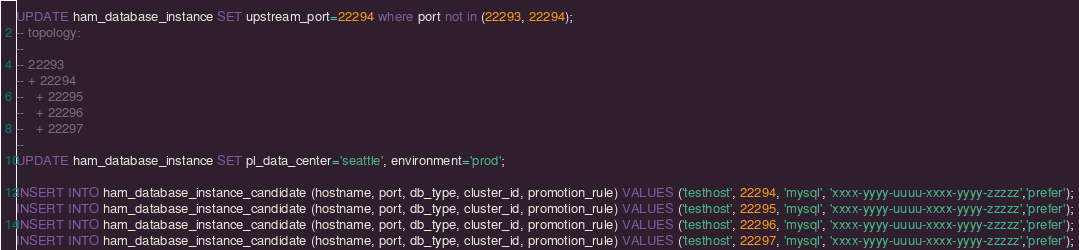<code> <loc_0><loc_0><loc_500><loc_500><_SQL_>UPDATE ham_database_instance SET upstream_port=22294 where port not in (22293, 22294);
-- topology:
--
-- 22293
-- + 22294
--   + 22295
--   + 22296
--   + 22297
--
UPDATE ham_database_instance SET pl_data_center='seattle', environment='prod';

INSERT INTO ham_database_instance_candidate (hostname, port, db_type, cluster_id, promotion_rule) VALUES ('testhost', 22294, 'mysql', 'xxxx-yyyy-uuuu-xxxx-yyyy-zzzzz','prefer');
INSERT INTO ham_database_instance_candidate (hostname, port, db_type, cluster_id, promotion_rule) VALUES ('testhost', 22295, 'mysql', 'xxxx-yyyy-uuuu-xxxx-yyyy-zzzzz','prefer');
INSERT INTO ham_database_instance_candidate (hostname, port, db_type, cluster_id, promotion_rule) VALUES ('testhost', 22296, 'mysql', 'xxxx-yyyy-uuuu-xxxx-yyyy-zzzzz','prefer');
INSERT INTO ham_database_instance_candidate (hostname, port, db_type, cluster_id, promotion_rule) VALUES ('testhost', 22297, 'mysql', 'xxxx-yyyy-uuuu-xxxx-yyyy-zzzzz','prefer');
</code> 